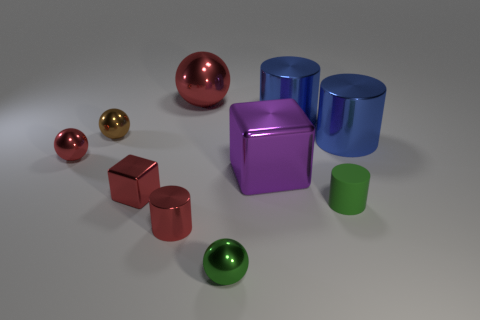Can you speculate about the possible purpose of this arrangement of objects? This arrangement appears to be a deliberate composition intended to showcase a variety of geometric shapes and colors, possibly for an artistic display or a graphic rendering exercise. Each object's distinct color and finish could serve to highlight different material properties, and the arrangement may be designed to create an aesthetically pleasing or visually instructive scene. 